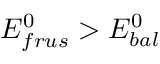Convert formula to latex. <formula><loc_0><loc_0><loc_500><loc_500>E _ { f r u s } ^ { 0 } > E _ { b a l } ^ { 0 }</formula> 